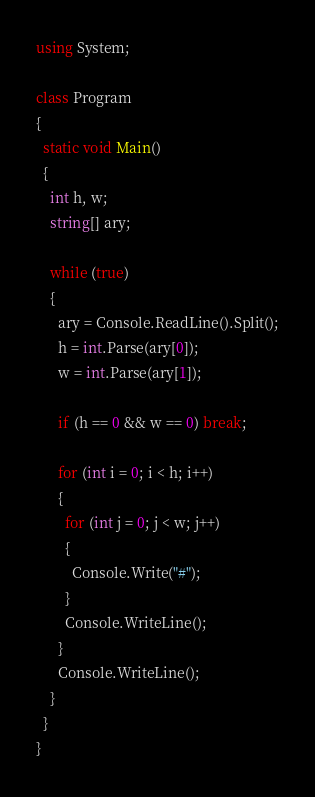<code> <loc_0><loc_0><loc_500><loc_500><_C#_>using System;

class Program
{
  static void Main()
  {
    int h, w;
    string[] ary;

    while (true)
    {
      ary = Console.ReadLine().Split();
      h = int.Parse(ary[0]);
      w = int.Parse(ary[1]);

      if (h == 0 && w == 0) break;

      for (int i = 0; i < h; i++)
      {
        for (int j = 0; j < w; j++)
        {
          Console.Write("#");
        }
        Console.WriteLine();
      }
      Console.WriteLine();
    }
  }
}</code> 